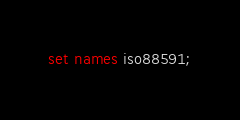<code> <loc_0><loc_0><loc_500><loc_500><_SQL_>
set names iso88591;


</code> 